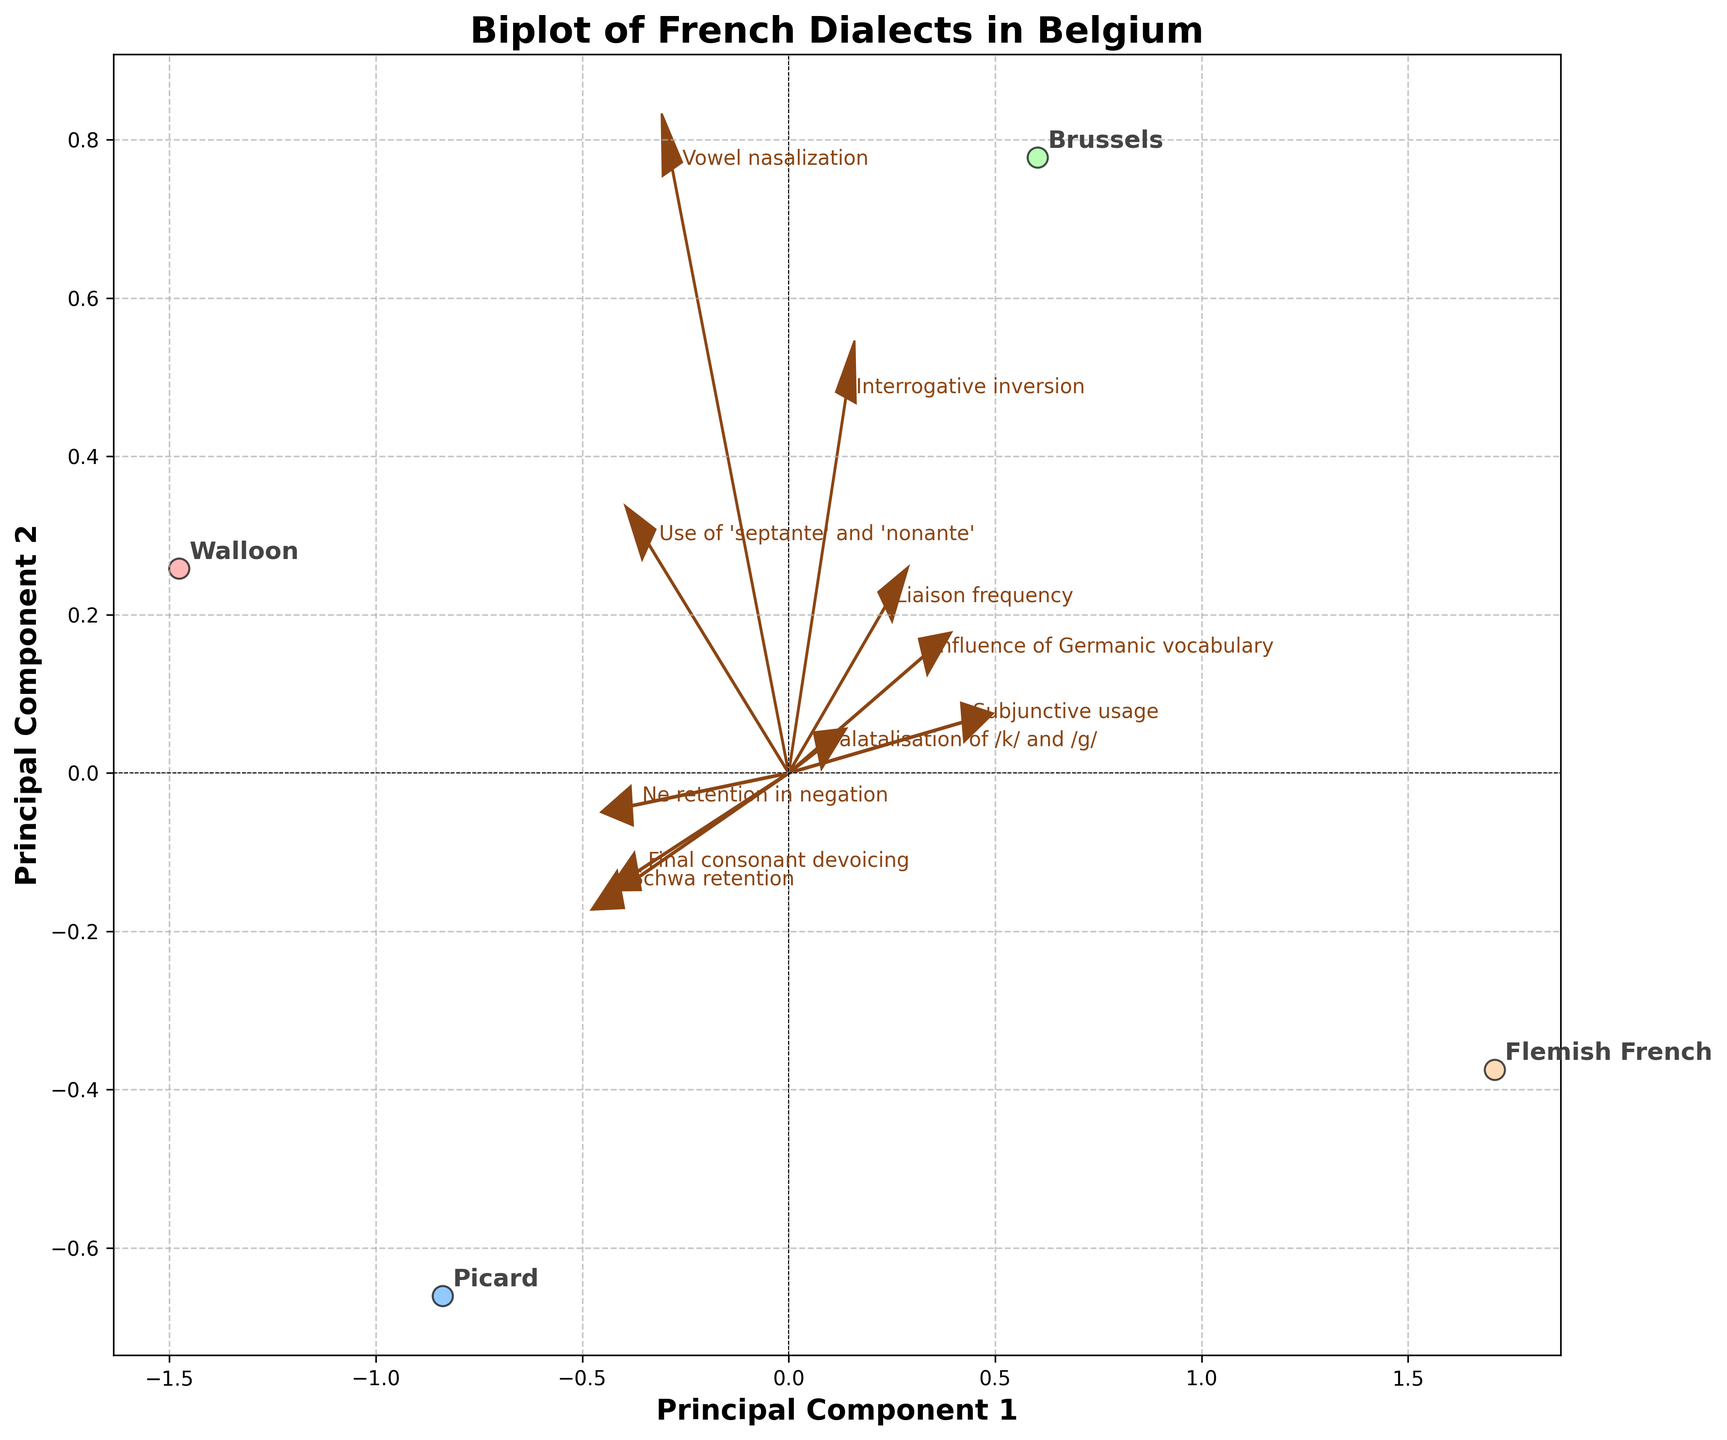What is the title of the plot? The title is displayed at the top of the plot. It provides an overview of the data being presented.
Answer: Biplot of French Dialects in Belgium How many dialects are represented in the plot? The dialects are the points that are labeled in the plot. Count these labels to get the number of dialects.
Answer: Four Which dialect has the highest value for Principal Component 1? To find this, locate the point furthest to the right along the x-axis, which represents Principal Component 1.
Answer: Walloon Which feature is most closely associated with Principal Component 2? Look for the feature arrow pointing closest to the top of the y-axis, as it indicates the most positive association with Principal Component 2.
Answer: Use of 'septante' and 'nonante' Does Picard dialect have a positive association with Ne retention in negation? Check the position of the Picard point relative to the Ne retention in negation arrow. If the arrow points toward the Picard point, it indicates a positive association.
Answer: Yes Which two features have the arrows pointing in opposite directions? Identify the feature arrows that point in nearly exact opposite directions, indicating that they are inversely related.
Answer: Ne retention in negation and Influence of Germanic vocabulary Compare the positions of Brussels and Flemish French dialects. What does their relative position indicate about their similarities? Observe the proximity of the Brussels and Flemish French points. Close points on the biplot suggest similar characteristics.
Answer: They are relatively close, indicating some similarities Which feature has the smallest influence on both principal components? Find the feature arrow that is closest to the origin (0,0), as it indicates minimal impact on both dimensions.
Answer: Influence of Germanic vocabulary If Ne retention in negation feature were to be projected onto the Brussels dialect, what would its approximate value be? Follow the direction of the Ne retention in negation arrow to project it onto the Brussels dialect point. Estimate the value based on its position relative to the origin and other points.
Answer: Approximately -0.4 